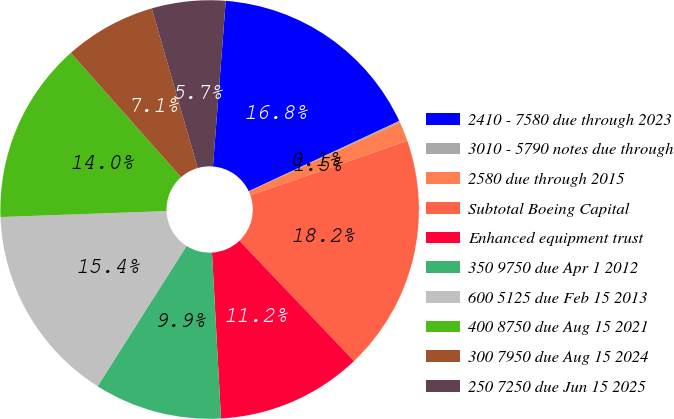Convert chart to OTSL. <chart><loc_0><loc_0><loc_500><loc_500><pie_chart><fcel>2410 - 7580 due through 2023<fcel>3010 - 5790 notes due through<fcel>2580 due through 2015<fcel>Subtotal Boeing Capital<fcel>Enhanced equipment trust<fcel>350 9750 due Apr 1 2012<fcel>600 5125 due Feb 15 2013<fcel>400 8750 due Aug 15 2021<fcel>300 7950 due Aug 15 2024<fcel>250 7250 due Jun 15 2025<nl><fcel>16.82%<fcel>0.12%<fcel>1.51%<fcel>18.21%<fcel>11.25%<fcel>9.86%<fcel>15.43%<fcel>14.03%<fcel>7.08%<fcel>5.69%<nl></chart> 